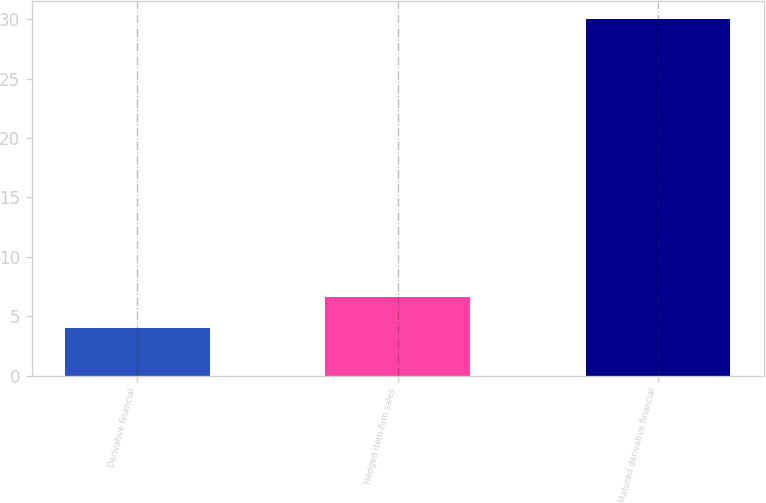<chart> <loc_0><loc_0><loc_500><loc_500><bar_chart><fcel>Derivative financial<fcel>Hedged item-firm sales<fcel>Matured derivative financial<nl><fcel>4<fcel>6.6<fcel>30<nl></chart> 